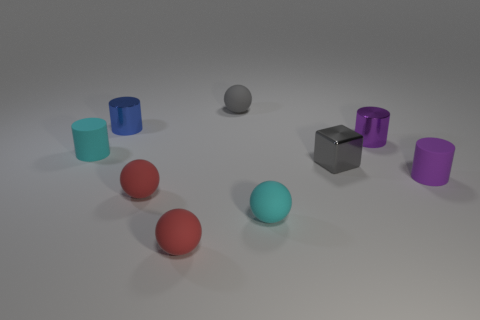Subtract 1 cylinders. How many cylinders are left? 3 Add 1 metal cubes. How many objects exist? 10 Subtract all cylinders. How many objects are left? 5 Add 6 metal objects. How many metal objects are left? 9 Add 7 blue objects. How many blue objects exist? 8 Subtract 0 red cylinders. How many objects are left? 9 Subtract all red rubber blocks. Subtract all blue metal cylinders. How many objects are left? 8 